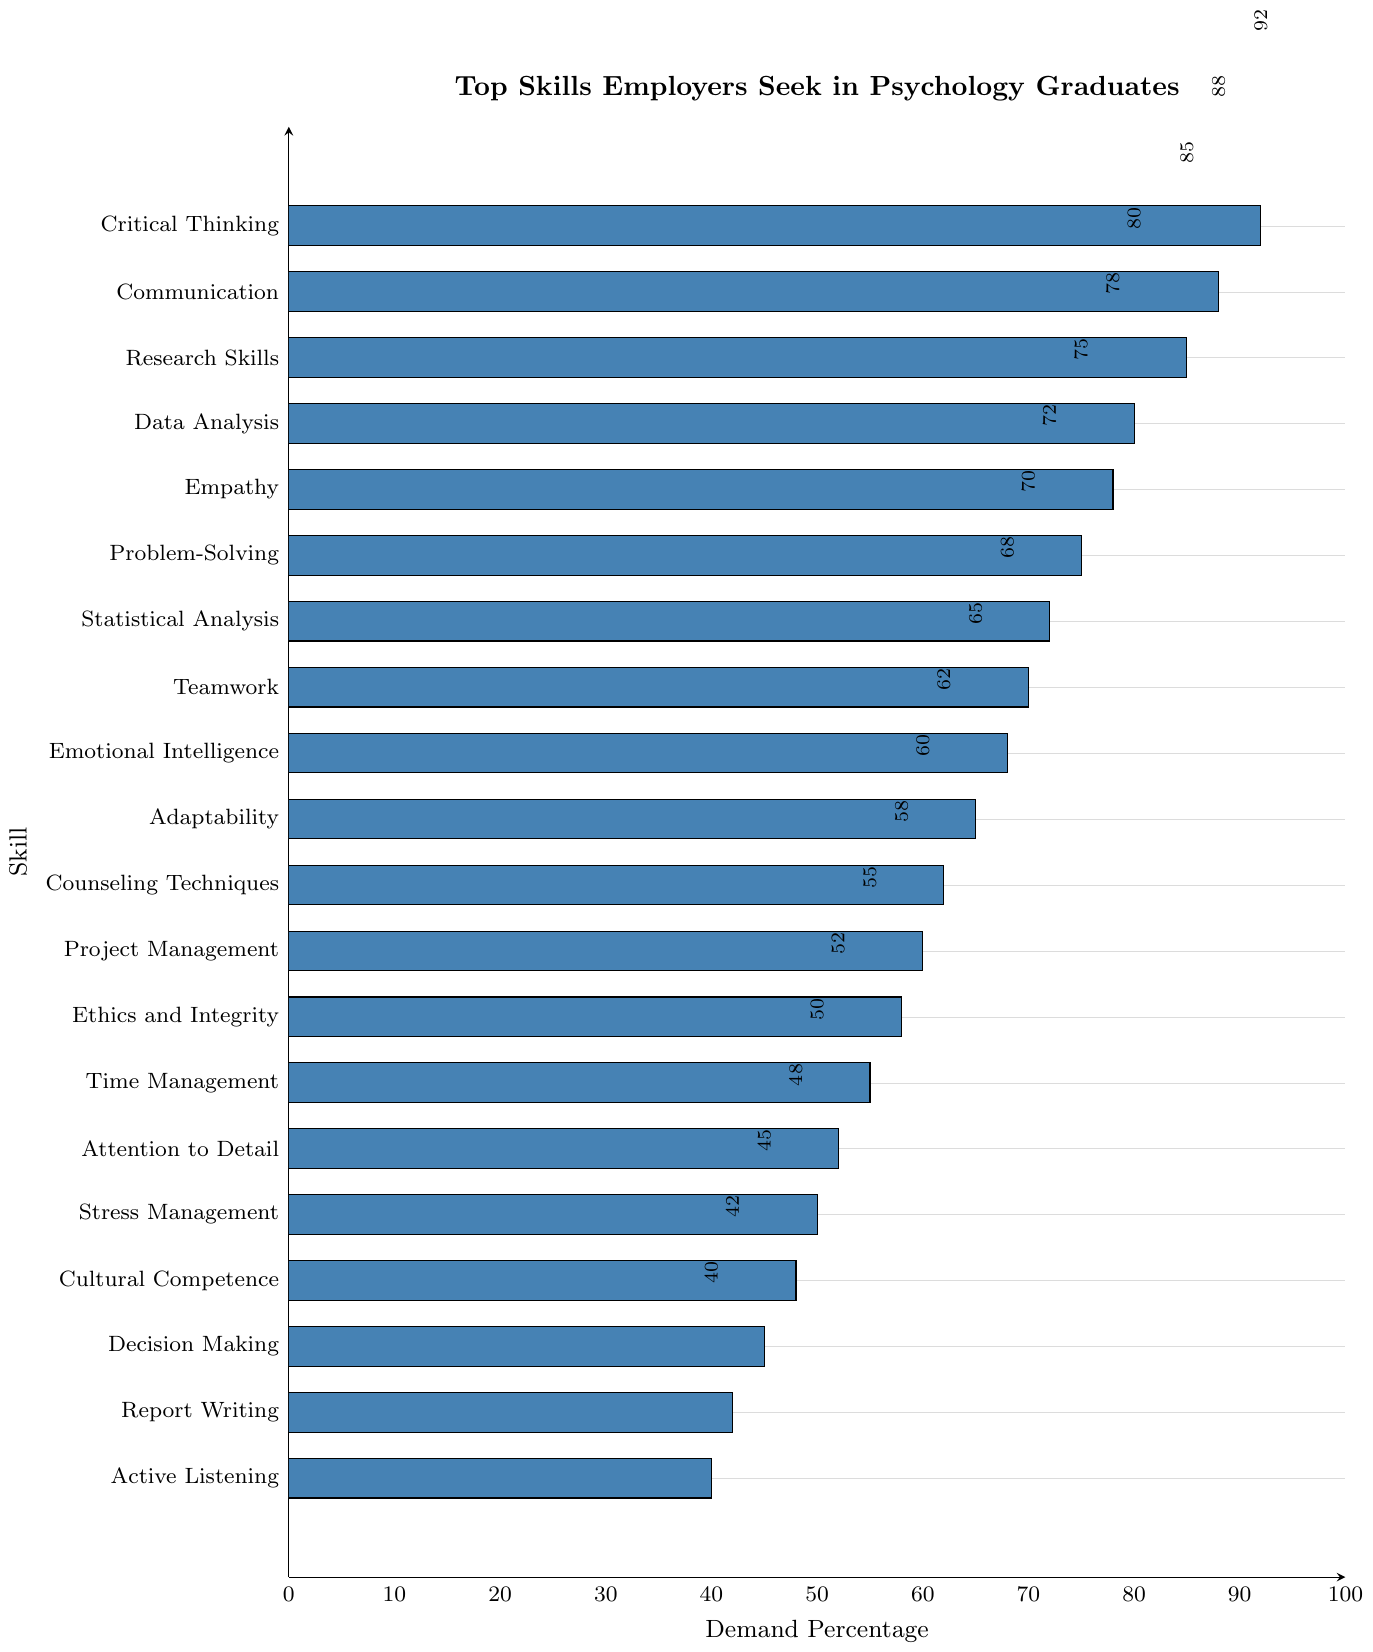Which skill has the highest demand percentage? The skill with the highest demand percentage has the tallest bar. The bar for "Critical Thinking" is the tallest, corresponding to a demand percentage of 92.
Answer: Critical Thinking What is the difference in demand percentage between Communication and Time Management? First, identify the demand percentages for Communication (88) and Time Management (55). Then, subtract the smaller percentage from the larger one: 88 - 55 = 33.
Answer: 33 Which skills have a demand percentage greater than 80? Identify all skills with bars extending beyond the 80% mark. The skills are Critical Thinking (92), Communication (88), Research Skills (85), and Data Analysis (80).
Answer: Critical Thinking, Communication, Research Skills, Data Analysis What is the average demand percentage of the top 3 most demanded skills? Calculate the average of the demand percentages of Critical Thinking (92), Communication (88), and Research Skills (85): (92 + 88 + 85) / 3 = 265 / 3 ≈ 88.33.
Answer: 88.33 Among Empathy and Adaptability, which skill has a higher demand percentage and by how much? Compare the demand percentages for Empathy (78) and Adaptability (65). Empathy has a higher demand. Subtract the smaller percentage from the larger one: 78 - 65 = 13.
Answer: Empathy by 13 What percentage of demand separates Statistical Analysis and Project Management? Identify the demand percentages for Statistical Analysis (72) and Project Management (60). Then, subtract the smaller percentage from the larger one: 72 - 60 = 12.
Answer: 12 How many skills have a demand percentage between 50 and 70? Count the skills with a demand percentage within the range of 50 to 70. These skills are Stress Management, Attention to Detail, Time Management, Ethics and Integrity, Project Management, Counseling Techniques, and Adaptability (7 skills).
Answer: 7 What is the median demand percentage of all the skills listed? List the demand percentages in ascending order and find the middle value. The ordered percentages are (40, 42, 45, 48, 50, 52, 55, 58, 60, 62, 65, 68, 70, 72, 75, 78, 80, 85, 88, 92). With 20 values, the median is the average of the 10th (62) and 11th (65) values: (62 + 65) / 2 = 63.5.
Answer: 63.5 Which skill has a demand percentage closest to the average demand percentage of all skills? Calculate the average demand percentage: (sum of all percentages) / 20. The sum is 1393, so the average is 1393 / 20 = 69.65. The closest skill percentages are Adaptability (65) and Emotional Intelligence (68). Emotional Intelligence is closest.
Answer: Emotional Intelligence 